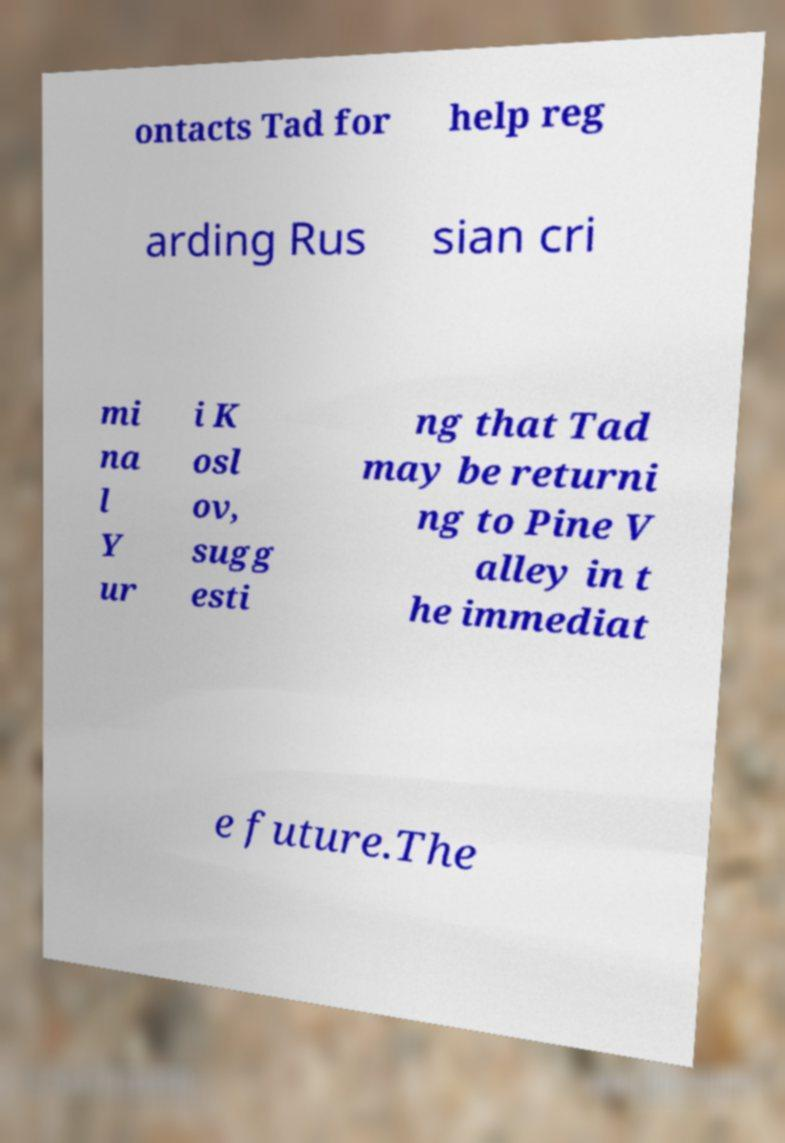For documentation purposes, I need the text within this image transcribed. Could you provide that? ontacts Tad for help reg arding Rus sian cri mi na l Y ur i K osl ov, sugg esti ng that Tad may be returni ng to Pine V alley in t he immediat e future.The 